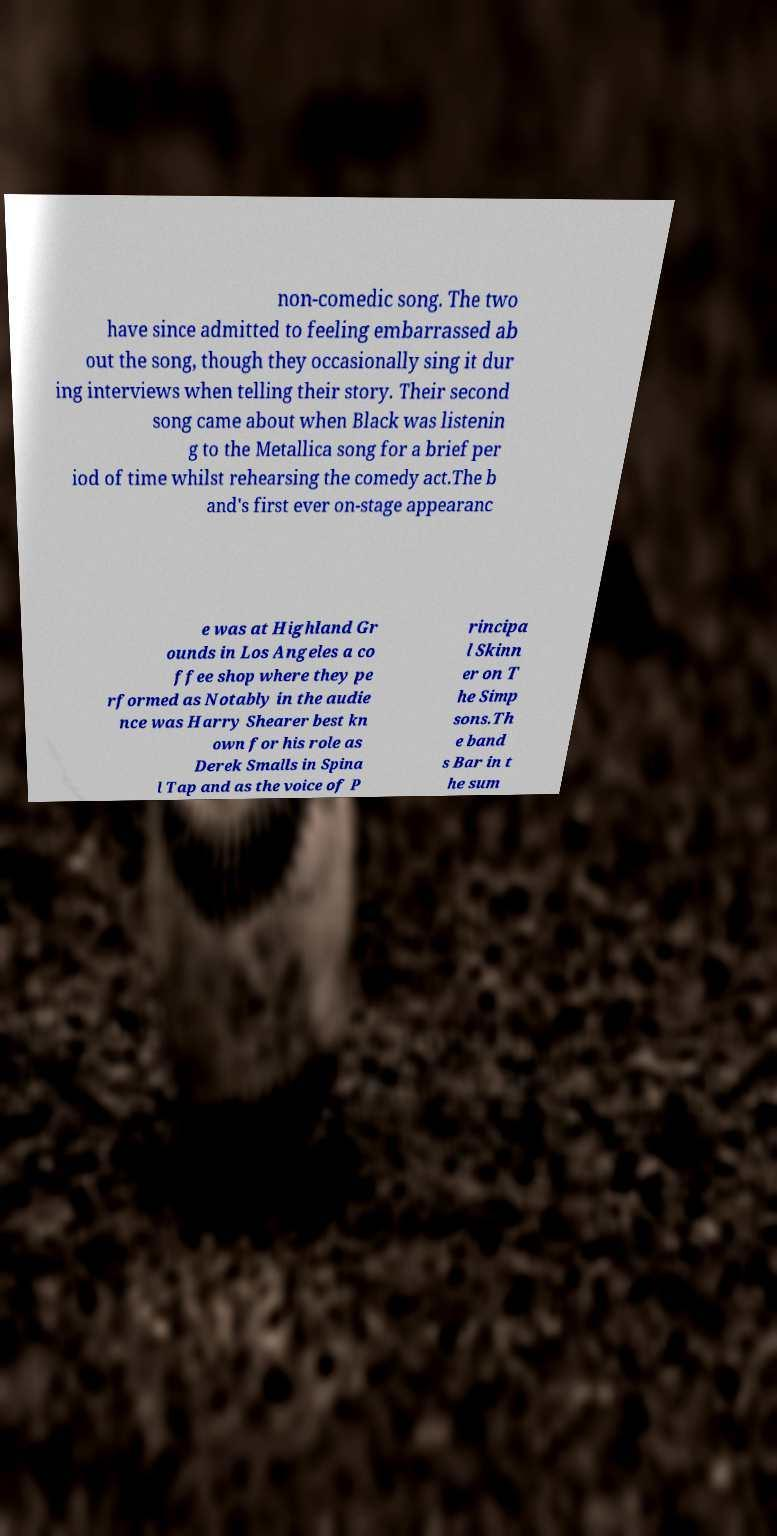I need the written content from this picture converted into text. Can you do that? non-comedic song. The two have since admitted to feeling embarrassed ab out the song, though they occasionally sing it dur ing interviews when telling their story. Their second song came about when Black was listenin g to the Metallica song for a brief per iod of time whilst rehearsing the comedy act.The b and's first ever on-stage appearanc e was at Highland Gr ounds in Los Angeles a co ffee shop where they pe rformed as Notably in the audie nce was Harry Shearer best kn own for his role as Derek Smalls in Spina l Tap and as the voice of P rincipa l Skinn er on T he Simp sons.Th e band s Bar in t he sum 